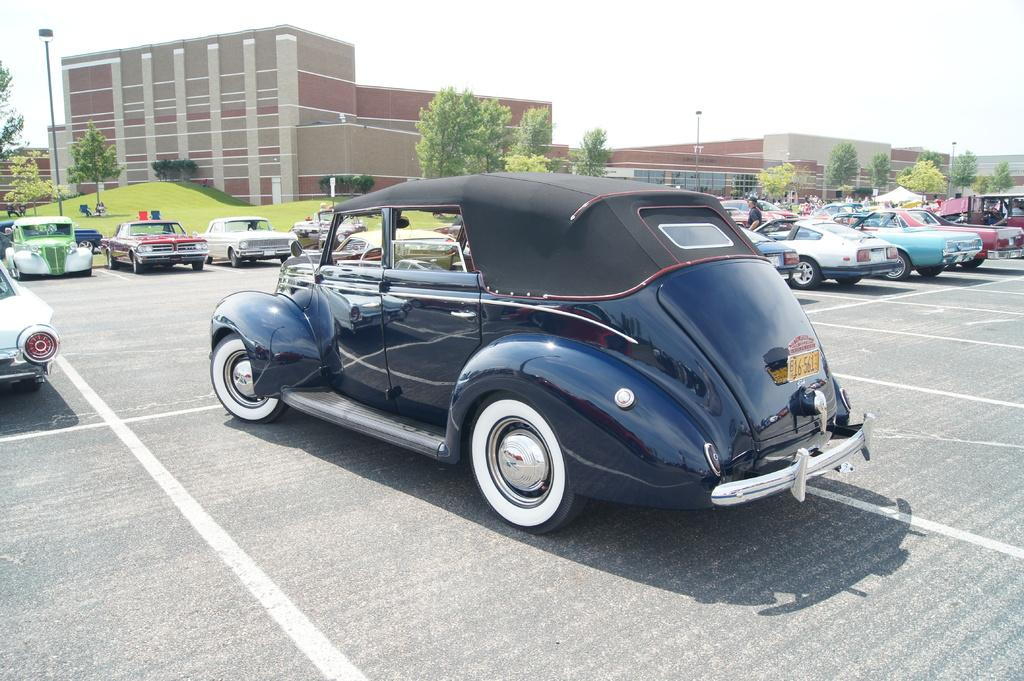What can be seen on the road in the image? There are vehicles on the road in the image. Who or what else is present in the image? There is a group of people and a stall in the image. Can you describe the surroundings in the image? There is a building, trees, poles, and lights in the image. What type of seating is available in the image? There are chairs in the image. What can be seen in the background of the image? The sky is visible in the background of the image. What type of bread is being sold at the stall in the image? There is no bread being sold at the stall in the image; it is not mentioned in the provided facts. Can you see any stars in the image? There are no stars visible in the image; only the sky is mentioned in the background. 